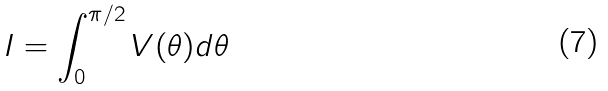Convert formula to latex. <formula><loc_0><loc_0><loc_500><loc_500>I = \int _ { 0 } ^ { \pi / 2 } V ( \theta ) d \theta</formula> 